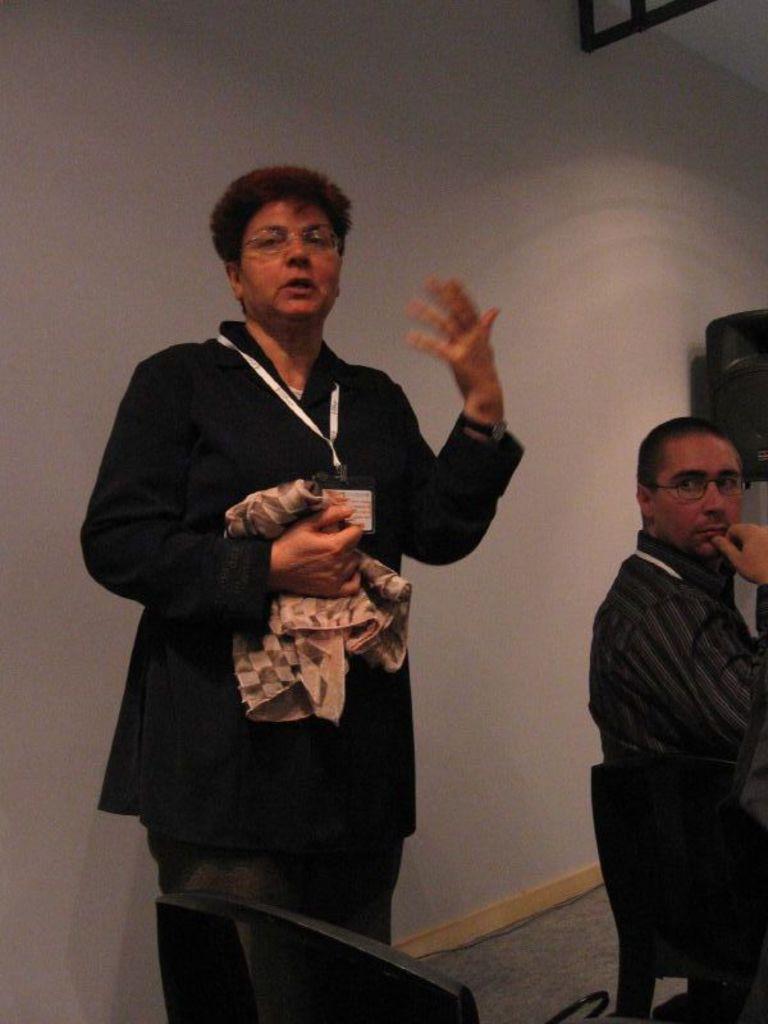Could you give a brief overview of what you see in this image? In this image there is a woman standing and talking, she is wearing an identity card, she is holding a cloth, there are chairs, there is a man sitting on the chair, at the background of the image there is the wall, there is an object towards the top of the image, there is an object towards the right of the image. 